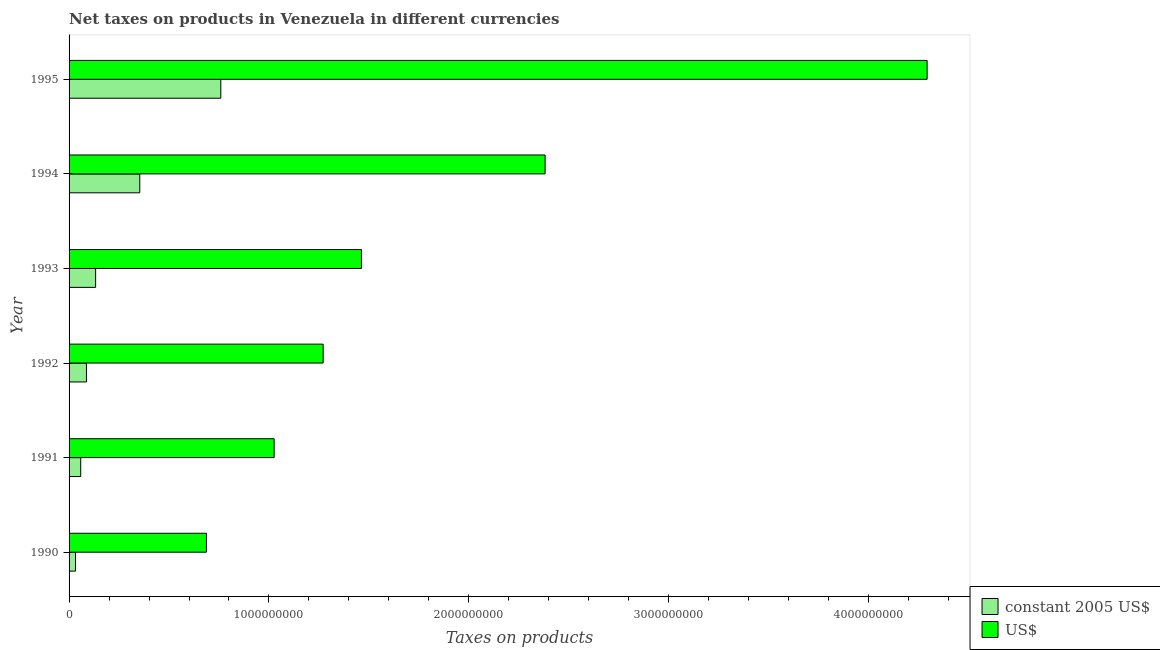How many different coloured bars are there?
Your answer should be very brief. 2. How many groups of bars are there?
Offer a very short reply. 6. Are the number of bars per tick equal to the number of legend labels?
Ensure brevity in your answer.  Yes. How many bars are there on the 4th tick from the top?
Ensure brevity in your answer.  2. What is the label of the 5th group of bars from the top?
Ensure brevity in your answer.  1991. In how many cases, is the number of bars for a given year not equal to the number of legend labels?
Your response must be concise. 0. What is the net taxes in us$ in 1994?
Offer a very short reply. 2.38e+09. Across all years, what is the maximum net taxes in constant 2005 us$?
Make the answer very short. 7.59e+08. Across all years, what is the minimum net taxes in constant 2005 us$?
Your answer should be compact. 3.22e+07. In which year was the net taxes in us$ maximum?
Offer a terse response. 1995. What is the total net taxes in us$ in the graph?
Offer a terse response. 1.11e+1. What is the difference between the net taxes in us$ in 1990 and that in 1992?
Provide a short and direct response. -5.84e+08. What is the difference between the net taxes in us$ in 1990 and the net taxes in constant 2005 us$ in 1993?
Make the answer very short. 5.54e+08. What is the average net taxes in us$ per year?
Give a very brief answer. 1.85e+09. In the year 1990, what is the difference between the net taxes in us$ and net taxes in constant 2005 us$?
Provide a short and direct response. 6.55e+08. What is the ratio of the net taxes in us$ in 1993 to that in 1995?
Offer a very short reply. 0.34. Is the net taxes in us$ in 1990 less than that in 1992?
Ensure brevity in your answer.  Yes. Is the difference between the net taxes in constant 2005 us$ in 1994 and 1995 greater than the difference between the net taxes in us$ in 1994 and 1995?
Provide a succinct answer. Yes. What is the difference between the highest and the second highest net taxes in constant 2005 us$?
Provide a short and direct response. 4.05e+08. What is the difference between the highest and the lowest net taxes in us$?
Your answer should be compact. 3.61e+09. Is the sum of the net taxes in us$ in 1992 and 1994 greater than the maximum net taxes in constant 2005 us$ across all years?
Provide a short and direct response. Yes. What does the 1st bar from the top in 1995 represents?
Give a very brief answer. US$. What does the 2nd bar from the bottom in 1990 represents?
Offer a very short reply. US$. Are all the bars in the graph horizontal?
Your answer should be very brief. Yes. How many years are there in the graph?
Provide a succinct answer. 6. Does the graph contain any zero values?
Your answer should be compact. No. What is the title of the graph?
Give a very brief answer. Net taxes on products in Venezuela in different currencies. Does "Urban" appear as one of the legend labels in the graph?
Provide a short and direct response. No. What is the label or title of the X-axis?
Keep it short and to the point. Taxes on products. What is the Taxes on products in constant 2005 US$ in 1990?
Keep it short and to the point. 3.22e+07. What is the Taxes on products in US$ in 1990?
Provide a short and direct response. 6.87e+08. What is the Taxes on products of constant 2005 US$ in 1991?
Offer a very short reply. 5.83e+07. What is the Taxes on products in US$ in 1991?
Offer a terse response. 1.03e+09. What is the Taxes on products of constant 2005 US$ in 1992?
Make the answer very short. 8.69e+07. What is the Taxes on products of US$ in 1992?
Make the answer very short. 1.27e+09. What is the Taxes on products of constant 2005 US$ in 1993?
Offer a very short reply. 1.33e+08. What is the Taxes on products of US$ in 1993?
Ensure brevity in your answer.  1.46e+09. What is the Taxes on products of constant 2005 US$ in 1994?
Offer a very short reply. 3.54e+08. What is the Taxes on products of US$ in 1994?
Offer a terse response. 2.38e+09. What is the Taxes on products of constant 2005 US$ in 1995?
Give a very brief answer. 7.59e+08. What is the Taxes on products of US$ in 1995?
Offer a very short reply. 4.29e+09. Across all years, what is the maximum Taxes on products of constant 2005 US$?
Provide a succinct answer. 7.59e+08. Across all years, what is the maximum Taxes on products in US$?
Your answer should be very brief. 4.29e+09. Across all years, what is the minimum Taxes on products in constant 2005 US$?
Provide a succinct answer. 3.22e+07. Across all years, what is the minimum Taxes on products of US$?
Ensure brevity in your answer.  6.87e+08. What is the total Taxes on products of constant 2005 US$ in the graph?
Ensure brevity in your answer.  1.42e+09. What is the total Taxes on products in US$ in the graph?
Your answer should be very brief. 1.11e+1. What is the difference between the Taxes on products of constant 2005 US$ in 1990 and that in 1991?
Your answer should be compact. -2.61e+07. What is the difference between the Taxes on products in US$ in 1990 and that in 1991?
Offer a terse response. -3.39e+08. What is the difference between the Taxes on products in constant 2005 US$ in 1990 and that in 1992?
Your response must be concise. -5.47e+07. What is the difference between the Taxes on products of US$ in 1990 and that in 1992?
Provide a short and direct response. -5.84e+08. What is the difference between the Taxes on products of constant 2005 US$ in 1990 and that in 1993?
Give a very brief answer. -1.01e+08. What is the difference between the Taxes on products of US$ in 1990 and that in 1993?
Make the answer very short. -7.75e+08. What is the difference between the Taxes on products in constant 2005 US$ in 1990 and that in 1994?
Your response must be concise. -3.21e+08. What is the difference between the Taxes on products in US$ in 1990 and that in 1994?
Offer a very short reply. -1.69e+09. What is the difference between the Taxes on products of constant 2005 US$ in 1990 and that in 1995?
Ensure brevity in your answer.  -7.27e+08. What is the difference between the Taxes on products in US$ in 1990 and that in 1995?
Offer a very short reply. -3.61e+09. What is the difference between the Taxes on products in constant 2005 US$ in 1991 and that in 1992?
Offer a terse response. -2.86e+07. What is the difference between the Taxes on products in US$ in 1991 and that in 1992?
Provide a succinct answer. -2.45e+08. What is the difference between the Taxes on products in constant 2005 US$ in 1991 and that in 1993?
Your answer should be very brief. -7.46e+07. What is the difference between the Taxes on products of US$ in 1991 and that in 1993?
Provide a succinct answer. -4.37e+08. What is the difference between the Taxes on products in constant 2005 US$ in 1991 and that in 1994?
Make the answer very short. -2.95e+08. What is the difference between the Taxes on products in US$ in 1991 and that in 1994?
Give a very brief answer. -1.36e+09. What is the difference between the Taxes on products in constant 2005 US$ in 1991 and that in 1995?
Your answer should be compact. -7.01e+08. What is the difference between the Taxes on products in US$ in 1991 and that in 1995?
Your answer should be very brief. -3.27e+09. What is the difference between the Taxes on products of constant 2005 US$ in 1992 and that in 1993?
Provide a succinct answer. -4.59e+07. What is the difference between the Taxes on products of US$ in 1992 and that in 1993?
Offer a terse response. -1.92e+08. What is the difference between the Taxes on products in constant 2005 US$ in 1992 and that in 1994?
Offer a terse response. -2.67e+08. What is the difference between the Taxes on products in US$ in 1992 and that in 1994?
Keep it short and to the point. -1.11e+09. What is the difference between the Taxes on products of constant 2005 US$ in 1992 and that in 1995?
Give a very brief answer. -6.72e+08. What is the difference between the Taxes on products of US$ in 1992 and that in 1995?
Your answer should be very brief. -3.02e+09. What is the difference between the Taxes on products of constant 2005 US$ in 1993 and that in 1994?
Provide a short and direct response. -2.21e+08. What is the difference between the Taxes on products of US$ in 1993 and that in 1994?
Keep it short and to the point. -9.19e+08. What is the difference between the Taxes on products in constant 2005 US$ in 1993 and that in 1995?
Provide a short and direct response. -6.26e+08. What is the difference between the Taxes on products in US$ in 1993 and that in 1995?
Provide a succinct answer. -2.83e+09. What is the difference between the Taxes on products of constant 2005 US$ in 1994 and that in 1995?
Ensure brevity in your answer.  -4.05e+08. What is the difference between the Taxes on products of US$ in 1994 and that in 1995?
Offer a terse response. -1.91e+09. What is the difference between the Taxes on products in constant 2005 US$ in 1990 and the Taxes on products in US$ in 1991?
Keep it short and to the point. -9.94e+08. What is the difference between the Taxes on products in constant 2005 US$ in 1990 and the Taxes on products in US$ in 1992?
Keep it short and to the point. -1.24e+09. What is the difference between the Taxes on products of constant 2005 US$ in 1990 and the Taxes on products of US$ in 1993?
Keep it short and to the point. -1.43e+09. What is the difference between the Taxes on products of constant 2005 US$ in 1990 and the Taxes on products of US$ in 1994?
Your response must be concise. -2.35e+09. What is the difference between the Taxes on products in constant 2005 US$ in 1990 and the Taxes on products in US$ in 1995?
Provide a short and direct response. -4.26e+09. What is the difference between the Taxes on products in constant 2005 US$ in 1991 and the Taxes on products in US$ in 1992?
Offer a terse response. -1.21e+09. What is the difference between the Taxes on products of constant 2005 US$ in 1991 and the Taxes on products of US$ in 1993?
Keep it short and to the point. -1.40e+09. What is the difference between the Taxes on products of constant 2005 US$ in 1991 and the Taxes on products of US$ in 1994?
Make the answer very short. -2.32e+09. What is the difference between the Taxes on products of constant 2005 US$ in 1991 and the Taxes on products of US$ in 1995?
Offer a very short reply. -4.23e+09. What is the difference between the Taxes on products in constant 2005 US$ in 1992 and the Taxes on products in US$ in 1993?
Keep it short and to the point. -1.38e+09. What is the difference between the Taxes on products in constant 2005 US$ in 1992 and the Taxes on products in US$ in 1994?
Your answer should be very brief. -2.29e+09. What is the difference between the Taxes on products of constant 2005 US$ in 1992 and the Taxes on products of US$ in 1995?
Your answer should be compact. -4.21e+09. What is the difference between the Taxes on products of constant 2005 US$ in 1993 and the Taxes on products of US$ in 1994?
Offer a terse response. -2.25e+09. What is the difference between the Taxes on products of constant 2005 US$ in 1993 and the Taxes on products of US$ in 1995?
Your response must be concise. -4.16e+09. What is the difference between the Taxes on products of constant 2005 US$ in 1994 and the Taxes on products of US$ in 1995?
Give a very brief answer. -3.94e+09. What is the average Taxes on products of constant 2005 US$ per year?
Keep it short and to the point. 2.37e+08. What is the average Taxes on products in US$ per year?
Your answer should be very brief. 1.85e+09. In the year 1990, what is the difference between the Taxes on products in constant 2005 US$ and Taxes on products in US$?
Offer a very short reply. -6.55e+08. In the year 1991, what is the difference between the Taxes on products in constant 2005 US$ and Taxes on products in US$?
Your answer should be compact. -9.68e+08. In the year 1992, what is the difference between the Taxes on products in constant 2005 US$ and Taxes on products in US$?
Make the answer very short. -1.18e+09. In the year 1993, what is the difference between the Taxes on products of constant 2005 US$ and Taxes on products of US$?
Ensure brevity in your answer.  -1.33e+09. In the year 1994, what is the difference between the Taxes on products of constant 2005 US$ and Taxes on products of US$?
Your response must be concise. -2.03e+09. In the year 1995, what is the difference between the Taxes on products of constant 2005 US$ and Taxes on products of US$?
Your answer should be very brief. -3.53e+09. What is the ratio of the Taxes on products in constant 2005 US$ in 1990 to that in 1991?
Offer a terse response. 0.55. What is the ratio of the Taxes on products in US$ in 1990 to that in 1991?
Ensure brevity in your answer.  0.67. What is the ratio of the Taxes on products in constant 2005 US$ in 1990 to that in 1992?
Provide a succinct answer. 0.37. What is the ratio of the Taxes on products of US$ in 1990 to that in 1992?
Make the answer very short. 0.54. What is the ratio of the Taxes on products in constant 2005 US$ in 1990 to that in 1993?
Ensure brevity in your answer.  0.24. What is the ratio of the Taxes on products of US$ in 1990 to that in 1993?
Your response must be concise. 0.47. What is the ratio of the Taxes on products in constant 2005 US$ in 1990 to that in 1994?
Provide a succinct answer. 0.09. What is the ratio of the Taxes on products of US$ in 1990 to that in 1994?
Make the answer very short. 0.29. What is the ratio of the Taxes on products in constant 2005 US$ in 1990 to that in 1995?
Provide a short and direct response. 0.04. What is the ratio of the Taxes on products in US$ in 1990 to that in 1995?
Ensure brevity in your answer.  0.16. What is the ratio of the Taxes on products of constant 2005 US$ in 1991 to that in 1992?
Provide a short and direct response. 0.67. What is the ratio of the Taxes on products in US$ in 1991 to that in 1992?
Your answer should be very brief. 0.81. What is the ratio of the Taxes on products of constant 2005 US$ in 1991 to that in 1993?
Your response must be concise. 0.44. What is the ratio of the Taxes on products in US$ in 1991 to that in 1993?
Offer a very short reply. 0.7. What is the ratio of the Taxes on products in constant 2005 US$ in 1991 to that in 1994?
Offer a very short reply. 0.16. What is the ratio of the Taxes on products in US$ in 1991 to that in 1994?
Provide a succinct answer. 0.43. What is the ratio of the Taxes on products in constant 2005 US$ in 1991 to that in 1995?
Offer a terse response. 0.08. What is the ratio of the Taxes on products in US$ in 1991 to that in 1995?
Give a very brief answer. 0.24. What is the ratio of the Taxes on products of constant 2005 US$ in 1992 to that in 1993?
Keep it short and to the point. 0.65. What is the ratio of the Taxes on products in US$ in 1992 to that in 1993?
Your response must be concise. 0.87. What is the ratio of the Taxes on products in constant 2005 US$ in 1992 to that in 1994?
Keep it short and to the point. 0.25. What is the ratio of the Taxes on products of US$ in 1992 to that in 1994?
Offer a very short reply. 0.53. What is the ratio of the Taxes on products in constant 2005 US$ in 1992 to that in 1995?
Provide a succinct answer. 0.11. What is the ratio of the Taxes on products of US$ in 1992 to that in 1995?
Provide a succinct answer. 0.3. What is the ratio of the Taxes on products of constant 2005 US$ in 1993 to that in 1994?
Give a very brief answer. 0.38. What is the ratio of the Taxes on products in US$ in 1993 to that in 1994?
Give a very brief answer. 0.61. What is the ratio of the Taxes on products of constant 2005 US$ in 1993 to that in 1995?
Your answer should be very brief. 0.17. What is the ratio of the Taxes on products of US$ in 1993 to that in 1995?
Your answer should be compact. 0.34. What is the ratio of the Taxes on products in constant 2005 US$ in 1994 to that in 1995?
Provide a short and direct response. 0.47. What is the ratio of the Taxes on products in US$ in 1994 to that in 1995?
Your answer should be compact. 0.55. What is the difference between the highest and the second highest Taxes on products in constant 2005 US$?
Provide a short and direct response. 4.05e+08. What is the difference between the highest and the second highest Taxes on products in US$?
Your response must be concise. 1.91e+09. What is the difference between the highest and the lowest Taxes on products of constant 2005 US$?
Give a very brief answer. 7.27e+08. What is the difference between the highest and the lowest Taxes on products of US$?
Provide a succinct answer. 3.61e+09. 